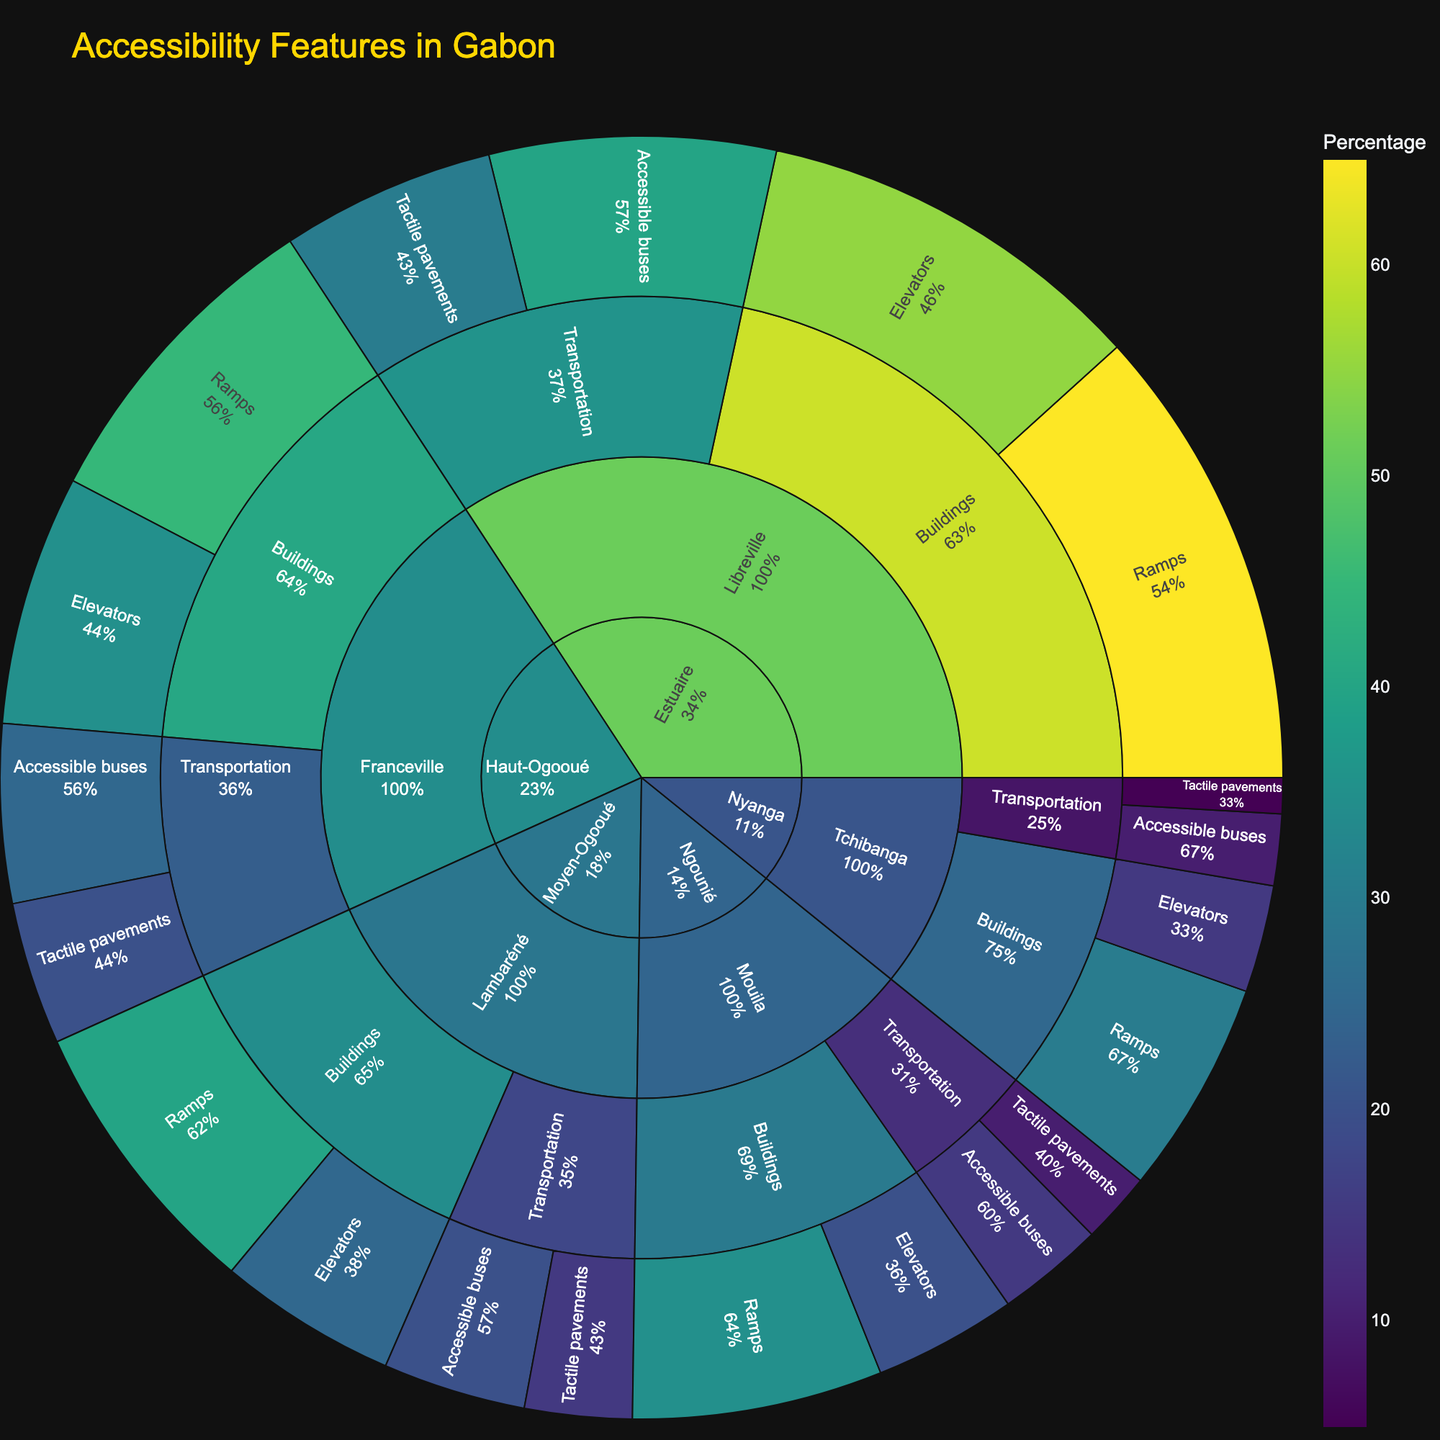What is the title of the figure? The title is usually at the top of the figure. By looking at the top, we can see the title "Accessibility Features in Gabon".
Answer: Accessibility Features in Gabon Which province has the highest percentage of ramps in buildings? To find this, look at the "Buildings" category and then find the "Ramps" feature in each province. Compare the percentages: Estuaire (65%), Haut-Ogooué (45%), Moyen-Ogooué (40%), Ngounié (35%), Nyanga (30%). Estuaire has the highest percentage.
Answer: Estuaire What percentage of accessible buses are there in Libreville? Focus on the "Transportation" category, then find the "Accessible buses" in Libreville which is in the province of Estuaire. The figure shows 40%.
Answer: 40% Which feature has a higher percentage in Franceville: Elevators in buildings or Tactile pavements in transportation? Look at Franceville under both the "Buildings" and "Transportation" categories. Elevators in buildings show 35%, while tactile pavements in transportation show 20%. So, Elevators have a higher percentage.
Answer: Elevators Among all the cities, which one has the lowest percentage of tactile pavements in transportation? Look at the "Transportation" category and check the percentages for tactile pavements in each city: Libreville (30%), Franceville (20%), Lambaréné (15%), Mouila (10%), Tchibanga (5%). Tchibanga has the lowest percentage.
Answer: Tchibanga Compare the percentage of elevators in buildings in Libreville and Lambaréné. Which city has a greater percentage, and by how much? Check the "Buildings" category for both cities. Libreville shows 55% for elevators, and Lambaréné shows 25%. Subtracting these gives: 55% - 25% = 30%. Libreville has a greater percentage by 30%.
Answer: Libreville, 30% What is the combined percentage of ramps and elevators in buildings in Mouila? Look at Mouila in the "Buildings" category. Ramps have 35%, and elevators have 20%. Adding these gives: 35% + 20% = 55%.
Answer: 55% How does the percentage of accessible buses in Lambaréné compare to that in Mouila? Check the "Transportation" category for both cities. Lambaréné has 20% accessible buses, and Mouila has 15%. Lambaréné has a higher percentage.
Answer: Lambaréné Which has a higher percentage in Tchibanga: Ramps in buildings or Accessible buses in transportation? For Tchibanga, under "Buildings" find ramps (30%) and under "Transportation" find accessible buses (10%). Ramps have a higher percentage.
Answer: Ramps What is the percentage of tactile pavements in transportation in Libreville as a proportion of the total percentage of tactile pavements across all cities? Find the percentage of tactile pavements across all cities: Libreville (30%), Franceville (20%), Lambaréné (15%), Mouila (10%), Tchibanga (5%). Total is: 30% + 20% + 15% + 10% + 5% = 80%. Libreville is 30%, so the proportion is: 30% / 80% = 0.375 or 37.5%.
Answer: 37.5% 